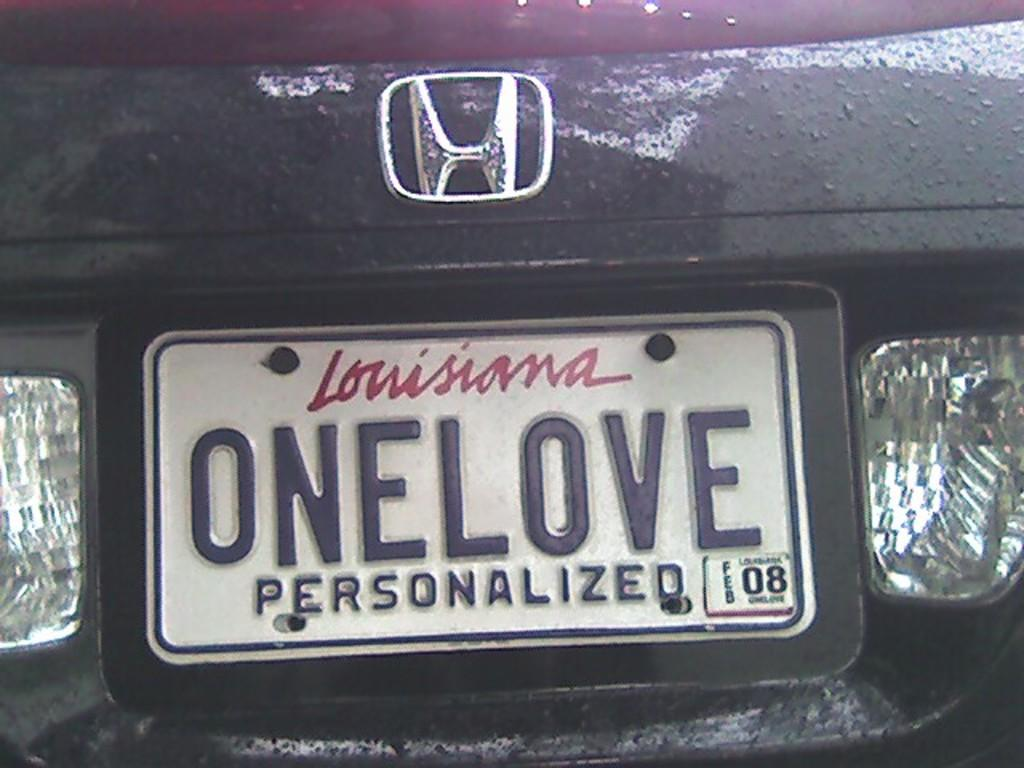<image>
Summarize the visual content of the image. the word onelove that is on the back of a license plate 